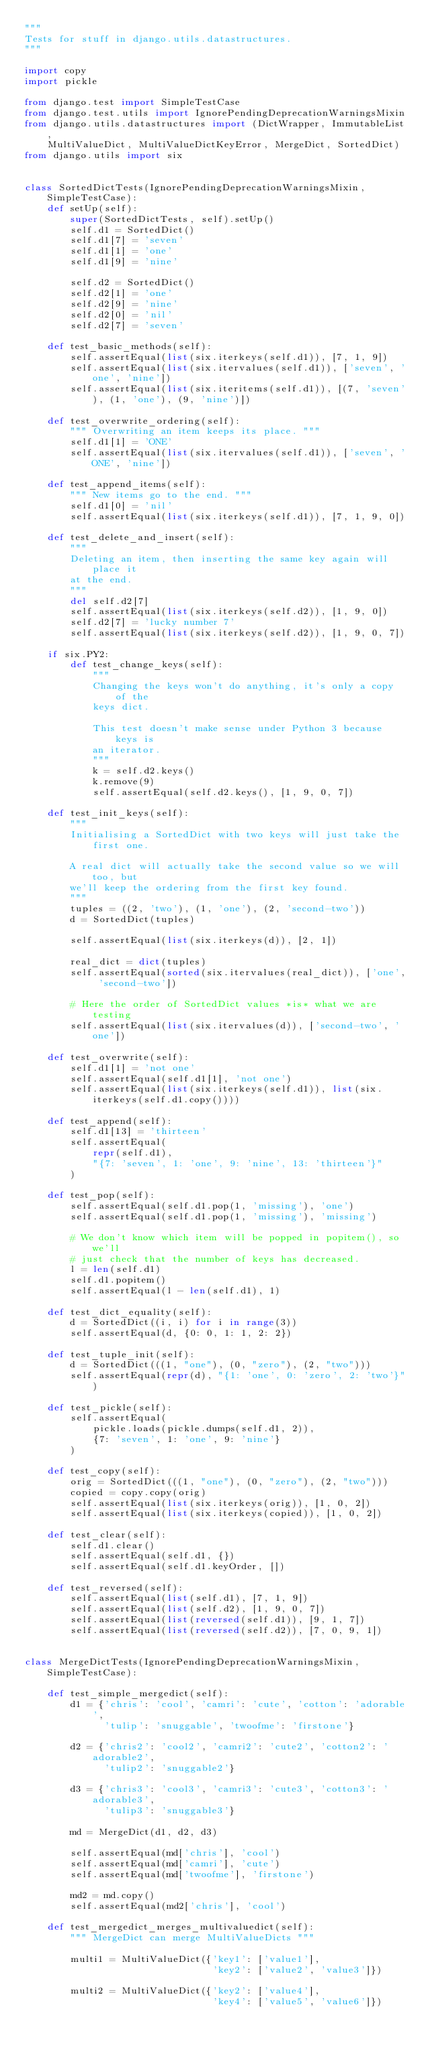Convert code to text. <code><loc_0><loc_0><loc_500><loc_500><_Python_>"""
Tests for stuff in django.utils.datastructures.
"""

import copy
import pickle

from django.test import SimpleTestCase
from django.test.utils import IgnorePendingDeprecationWarningsMixin
from django.utils.datastructures import (DictWrapper, ImmutableList,
    MultiValueDict, MultiValueDictKeyError, MergeDict, SortedDict)
from django.utils import six


class SortedDictTests(IgnorePendingDeprecationWarningsMixin, SimpleTestCase):
    def setUp(self):
        super(SortedDictTests, self).setUp()
        self.d1 = SortedDict()
        self.d1[7] = 'seven'
        self.d1[1] = 'one'
        self.d1[9] = 'nine'

        self.d2 = SortedDict()
        self.d2[1] = 'one'
        self.d2[9] = 'nine'
        self.d2[0] = 'nil'
        self.d2[7] = 'seven'

    def test_basic_methods(self):
        self.assertEqual(list(six.iterkeys(self.d1)), [7, 1, 9])
        self.assertEqual(list(six.itervalues(self.d1)), ['seven', 'one', 'nine'])
        self.assertEqual(list(six.iteritems(self.d1)), [(7, 'seven'), (1, 'one'), (9, 'nine')])

    def test_overwrite_ordering(self):
        """ Overwriting an item keeps its place. """
        self.d1[1] = 'ONE'
        self.assertEqual(list(six.itervalues(self.d1)), ['seven', 'ONE', 'nine'])

    def test_append_items(self):
        """ New items go to the end. """
        self.d1[0] = 'nil'
        self.assertEqual(list(six.iterkeys(self.d1)), [7, 1, 9, 0])

    def test_delete_and_insert(self):
        """
        Deleting an item, then inserting the same key again will place it
        at the end.
        """
        del self.d2[7]
        self.assertEqual(list(six.iterkeys(self.d2)), [1, 9, 0])
        self.d2[7] = 'lucky number 7'
        self.assertEqual(list(six.iterkeys(self.d2)), [1, 9, 0, 7])

    if six.PY2:
        def test_change_keys(self):
            """
            Changing the keys won't do anything, it's only a copy of the
            keys dict.

            This test doesn't make sense under Python 3 because keys is
            an iterator.
            """
            k = self.d2.keys()
            k.remove(9)
            self.assertEqual(self.d2.keys(), [1, 9, 0, 7])

    def test_init_keys(self):
        """
        Initialising a SortedDict with two keys will just take the first one.

        A real dict will actually take the second value so we will too, but
        we'll keep the ordering from the first key found.
        """
        tuples = ((2, 'two'), (1, 'one'), (2, 'second-two'))
        d = SortedDict(tuples)

        self.assertEqual(list(six.iterkeys(d)), [2, 1])

        real_dict = dict(tuples)
        self.assertEqual(sorted(six.itervalues(real_dict)), ['one', 'second-two'])

        # Here the order of SortedDict values *is* what we are testing
        self.assertEqual(list(six.itervalues(d)), ['second-two', 'one'])

    def test_overwrite(self):
        self.d1[1] = 'not one'
        self.assertEqual(self.d1[1], 'not one')
        self.assertEqual(list(six.iterkeys(self.d1)), list(six.iterkeys(self.d1.copy())))

    def test_append(self):
        self.d1[13] = 'thirteen'
        self.assertEqual(
            repr(self.d1),
            "{7: 'seven', 1: 'one', 9: 'nine', 13: 'thirteen'}"
        )

    def test_pop(self):
        self.assertEqual(self.d1.pop(1, 'missing'), 'one')
        self.assertEqual(self.d1.pop(1, 'missing'), 'missing')

        # We don't know which item will be popped in popitem(), so we'll
        # just check that the number of keys has decreased.
        l = len(self.d1)
        self.d1.popitem()
        self.assertEqual(l - len(self.d1), 1)

    def test_dict_equality(self):
        d = SortedDict((i, i) for i in range(3))
        self.assertEqual(d, {0: 0, 1: 1, 2: 2})

    def test_tuple_init(self):
        d = SortedDict(((1, "one"), (0, "zero"), (2, "two")))
        self.assertEqual(repr(d), "{1: 'one', 0: 'zero', 2: 'two'}")

    def test_pickle(self):
        self.assertEqual(
            pickle.loads(pickle.dumps(self.d1, 2)),
            {7: 'seven', 1: 'one', 9: 'nine'}
        )

    def test_copy(self):
        orig = SortedDict(((1, "one"), (0, "zero"), (2, "two")))
        copied = copy.copy(orig)
        self.assertEqual(list(six.iterkeys(orig)), [1, 0, 2])
        self.assertEqual(list(six.iterkeys(copied)), [1, 0, 2])

    def test_clear(self):
        self.d1.clear()
        self.assertEqual(self.d1, {})
        self.assertEqual(self.d1.keyOrder, [])

    def test_reversed(self):
        self.assertEqual(list(self.d1), [7, 1, 9])
        self.assertEqual(list(self.d2), [1, 9, 0, 7])
        self.assertEqual(list(reversed(self.d1)), [9, 1, 7])
        self.assertEqual(list(reversed(self.d2)), [7, 0, 9, 1])


class MergeDictTests(IgnorePendingDeprecationWarningsMixin, SimpleTestCase):

    def test_simple_mergedict(self):
        d1 = {'chris': 'cool', 'camri': 'cute', 'cotton': 'adorable',
              'tulip': 'snuggable', 'twoofme': 'firstone'}

        d2 = {'chris2': 'cool2', 'camri2': 'cute2', 'cotton2': 'adorable2',
              'tulip2': 'snuggable2'}

        d3 = {'chris3': 'cool3', 'camri3': 'cute3', 'cotton3': 'adorable3',
              'tulip3': 'snuggable3'}

        md = MergeDict(d1, d2, d3)

        self.assertEqual(md['chris'], 'cool')
        self.assertEqual(md['camri'], 'cute')
        self.assertEqual(md['twoofme'], 'firstone')

        md2 = md.copy()
        self.assertEqual(md2['chris'], 'cool')

    def test_mergedict_merges_multivaluedict(self):
        """ MergeDict can merge MultiValueDicts """

        multi1 = MultiValueDict({'key1': ['value1'],
                                 'key2': ['value2', 'value3']})

        multi2 = MultiValueDict({'key2': ['value4'],
                                 'key4': ['value5', 'value6']})
</code> 